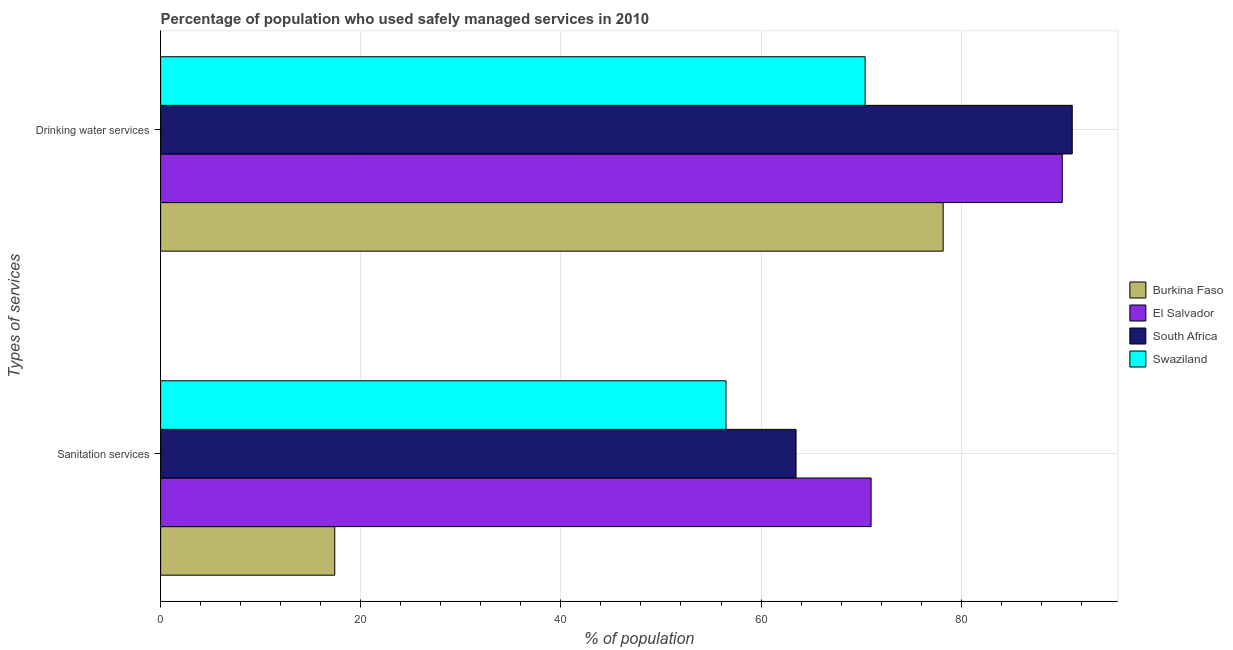How many different coloured bars are there?
Your response must be concise. 4. How many groups of bars are there?
Provide a short and direct response. 2. Are the number of bars on each tick of the Y-axis equal?
Your answer should be very brief. Yes. How many bars are there on the 1st tick from the top?
Keep it short and to the point. 4. How many bars are there on the 1st tick from the bottom?
Offer a very short reply. 4. What is the label of the 2nd group of bars from the top?
Your answer should be compact. Sanitation services. What is the percentage of population who used drinking water services in South Africa?
Offer a very short reply. 91.1. In which country was the percentage of population who used sanitation services maximum?
Your response must be concise. El Salvador. In which country was the percentage of population who used drinking water services minimum?
Offer a terse response. Swaziland. What is the total percentage of population who used drinking water services in the graph?
Your answer should be compact. 329.8. What is the difference between the percentage of population who used drinking water services in El Salvador and that in Swaziland?
Provide a succinct answer. 19.7. What is the difference between the percentage of population who used drinking water services in Burkina Faso and the percentage of population who used sanitation services in South Africa?
Your answer should be very brief. 14.7. What is the average percentage of population who used drinking water services per country?
Provide a succinct answer. 82.45. What is the difference between the percentage of population who used drinking water services and percentage of population who used sanitation services in Burkina Faso?
Offer a very short reply. 60.8. What is the ratio of the percentage of population who used sanitation services in Burkina Faso to that in Swaziland?
Your response must be concise. 0.31. In how many countries, is the percentage of population who used drinking water services greater than the average percentage of population who used drinking water services taken over all countries?
Offer a terse response. 2. What does the 1st bar from the top in Drinking water services represents?
Keep it short and to the point. Swaziland. What does the 3rd bar from the bottom in Sanitation services represents?
Offer a very short reply. South Africa. How many bars are there?
Your answer should be compact. 8. Does the graph contain any zero values?
Offer a terse response. No. Does the graph contain grids?
Keep it short and to the point. Yes. What is the title of the graph?
Keep it short and to the point. Percentage of population who used safely managed services in 2010. What is the label or title of the X-axis?
Keep it short and to the point. % of population. What is the label or title of the Y-axis?
Make the answer very short. Types of services. What is the % of population of Burkina Faso in Sanitation services?
Offer a very short reply. 17.4. What is the % of population in South Africa in Sanitation services?
Provide a short and direct response. 63.5. What is the % of population of Swaziland in Sanitation services?
Ensure brevity in your answer.  56.5. What is the % of population of Burkina Faso in Drinking water services?
Make the answer very short. 78.2. What is the % of population in El Salvador in Drinking water services?
Give a very brief answer. 90.1. What is the % of population in South Africa in Drinking water services?
Give a very brief answer. 91.1. What is the % of population in Swaziland in Drinking water services?
Give a very brief answer. 70.4. Across all Types of services, what is the maximum % of population of Burkina Faso?
Offer a very short reply. 78.2. Across all Types of services, what is the maximum % of population in El Salvador?
Give a very brief answer. 90.1. Across all Types of services, what is the maximum % of population in South Africa?
Offer a very short reply. 91.1. Across all Types of services, what is the maximum % of population in Swaziland?
Your answer should be compact. 70.4. Across all Types of services, what is the minimum % of population of El Salvador?
Provide a succinct answer. 71. Across all Types of services, what is the minimum % of population in South Africa?
Give a very brief answer. 63.5. Across all Types of services, what is the minimum % of population of Swaziland?
Ensure brevity in your answer.  56.5. What is the total % of population of Burkina Faso in the graph?
Provide a succinct answer. 95.6. What is the total % of population in El Salvador in the graph?
Make the answer very short. 161.1. What is the total % of population in South Africa in the graph?
Provide a succinct answer. 154.6. What is the total % of population in Swaziland in the graph?
Provide a short and direct response. 126.9. What is the difference between the % of population in Burkina Faso in Sanitation services and that in Drinking water services?
Ensure brevity in your answer.  -60.8. What is the difference between the % of population in El Salvador in Sanitation services and that in Drinking water services?
Your response must be concise. -19.1. What is the difference between the % of population in South Africa in Sanitation services and that in Drinking water services?
Offer a very short reply. -27.6. What is the difference between the % of population in Swaziland in Sanitation services and that in Drinking water services?
Provide a short and direct response. -13.9. What is the difference between the % of population of Burkina Faso in Sanitation services and the % of population of El Salvador in Drinking water services?
Ensure brevity in your answer.  -72.7. What is the difference between the % of population of Burkina Faso in Sanitation services and the % of population of South Africa in Drinking water services?
Offer a terse response. -73.7. What is the difference between the % of population in Burkina Faso in Sanitation services and the % of population in Swaziland in Drinking water services?
Provide a short and direct response. -53. What is the difference between the % of population in El Salvador in Sanitation services and the % of population in South Africa in Drinking water services?
Ensure brevity in your answer.  -20.1. What is the difference between the % of population of El Salvador in Sanitation services and the % of population of Swaziland in Drinking water services?
Offer a terse response. 0.6. What is the average % of population in Burkina Faso per Types of services?
Your answer should be compact. 47.8. What is the average % of population of El Salvador per Types of services?
Offer a terse response. 80.55. What is the average % of population of South Africa per Types of services?
Provide a succinct answer. 77.3. What is the average % of population of Swaziland per Types of services?
Your answer should be very brief. 63.45. What is the difference between the % of population of Burkina Faso and % of population of El Salvador in Sanitation services?
Provide a short and direct response. -53.6. What is the difference between the % of population of Burkina Faso and % of population of South Africa in Sanitation services?
Make the answer very short. -46.1. What is the difference between the % of population of Burkina Faso and % of population of Swaziland in Sanitation services?
Provide a short and direct response. -39.1. What is the difference between the % of population in El Salvador and % of population in South Africa in Sanitation services?
Keep it short and to the point. 7.5. What is the difference between the % of population of El Salvador and % of population of Swaziland in Sanitation services?
Provide a short and direct response. 14.5. What is the difference between the % of population of Burkina Faso and % of population of Swaziland in Drinking water services?
Keep it short and to the point. 7.8. What is the difference between the % of population in South Africa and % of population in Swaziland in Drinking water services?
Offer a terse response. 20.7. What is the ratio of the % of population in Burkina Faso in Sanitation services to that in Drinking water services?
Keep it short and to the point. 0.22. What is the ratio of the % of population in El Salvador in Sanitation services to that in Drinking water services?
Offer a very short reply. 0.79. What is the ratio of the % of population of South Africa in Sanitation services to that in Drinking water services?
Keep it short and to the point. 0.7. What is the ratio of the % of population of Swaziland in Sanitation services to that in Drinking water services?
Offer a very short reply. 0.8. What is the difference between the highest and the second highest % of population in Burkina Faso?
Provide a succinct answer. 60.8. What is the difference between the highest and the second highest % of population of South Africa?
Offer a very short reply. 27.6. What is the difference between the highest and the second highest % of population in Swaziland?
Ensure brevity in your answer.  13.9. What is the difference between the highest and the lowest % of population in Burkina Faso?
Your answer should be compact. 60.8. What is the difference between the highest and the lowest % of population of El Salvador?
Your answer should be compact. 19.1. What is the difference between the highest and the lowest % of population of South Africa?
Your response must be concise. 27.6. 